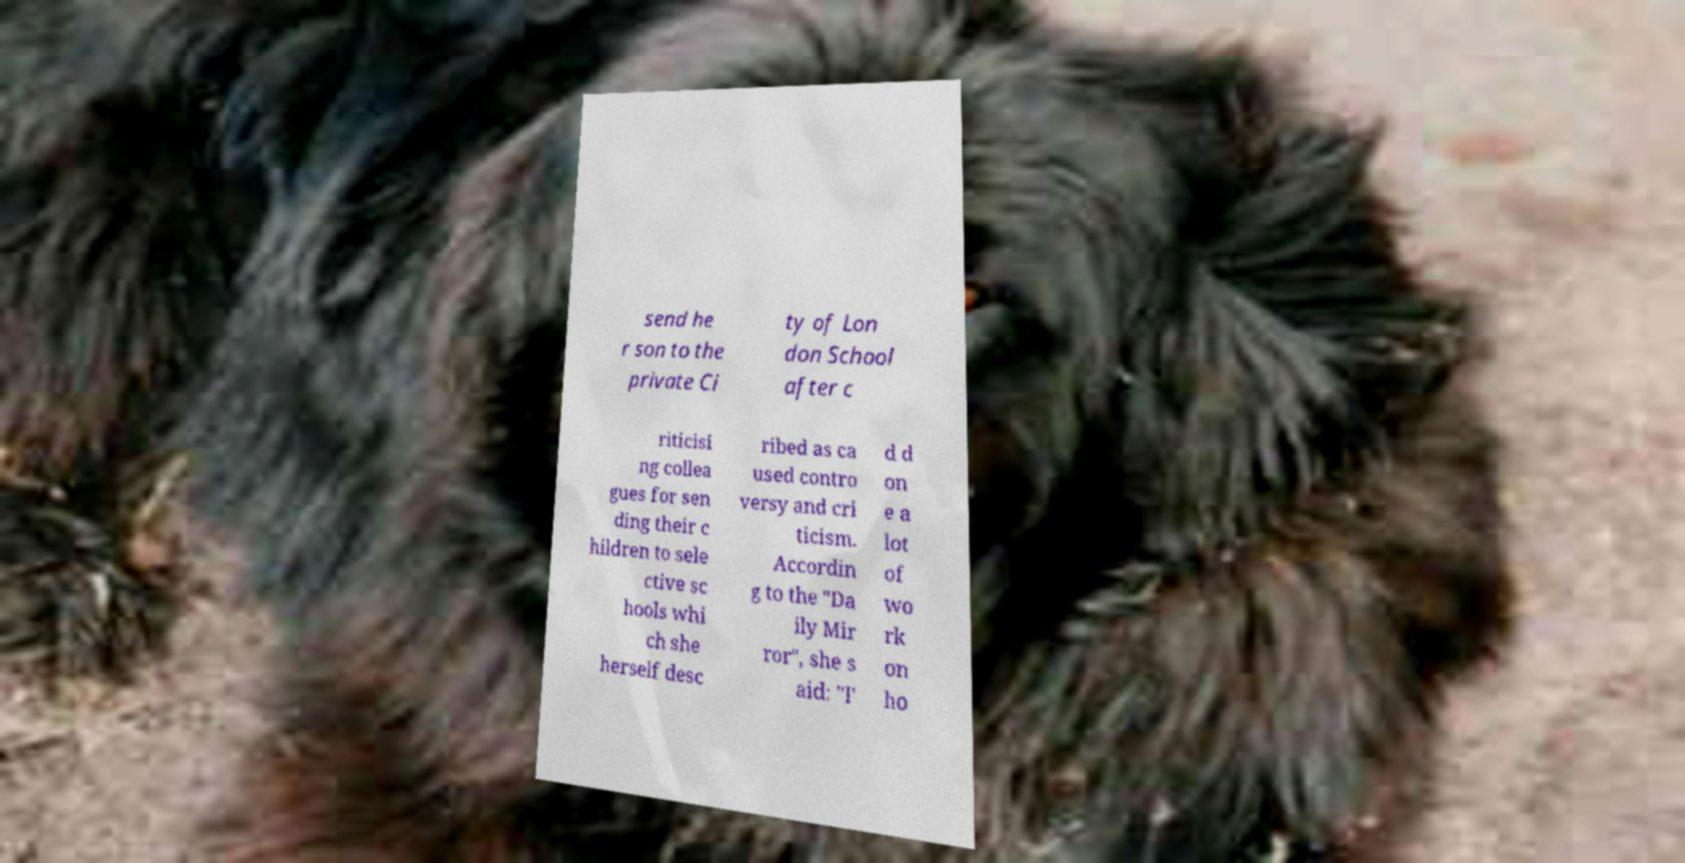Can you accurately transcribe the text from the provided image for me? send he r son to the private Ci ty of Lon don School after c riticisi ng collea gues for sen ding their c hildren to sele ctive sc hools whi ch she herself desc ribed as ca used contro versy and cri ticism. Accordin g to the "Da ily Mir ror", she s aid: "I' d d on e a lot of wo rk on ho 